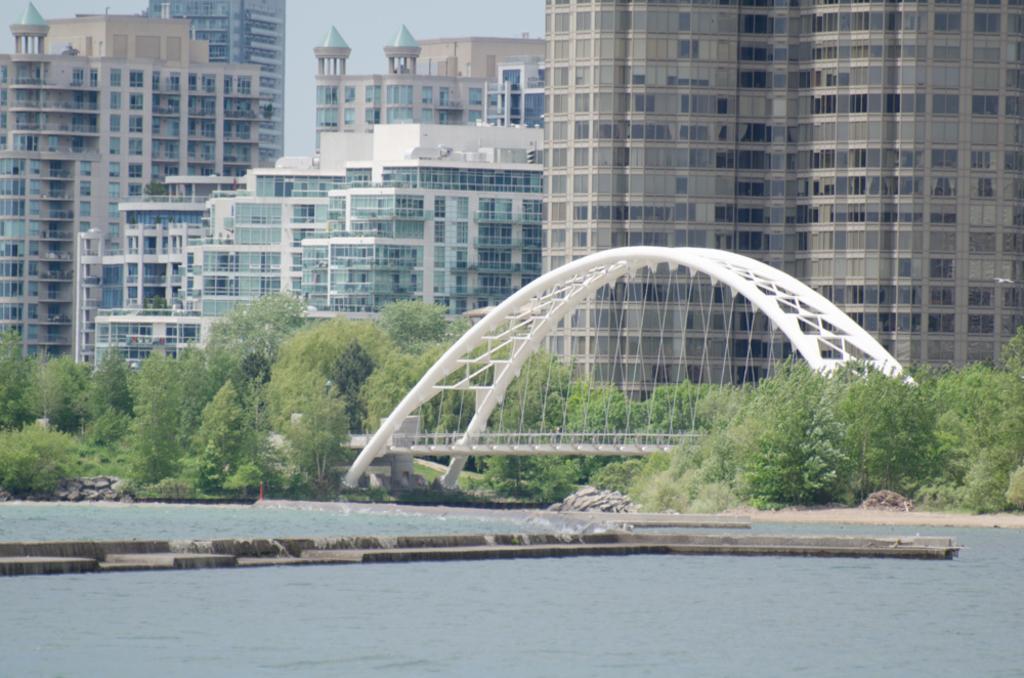Please provide a concise description of this image. In front of the image there is water. There are rocks, trees, buildings and a bridge. At the top of the image there is sky. 